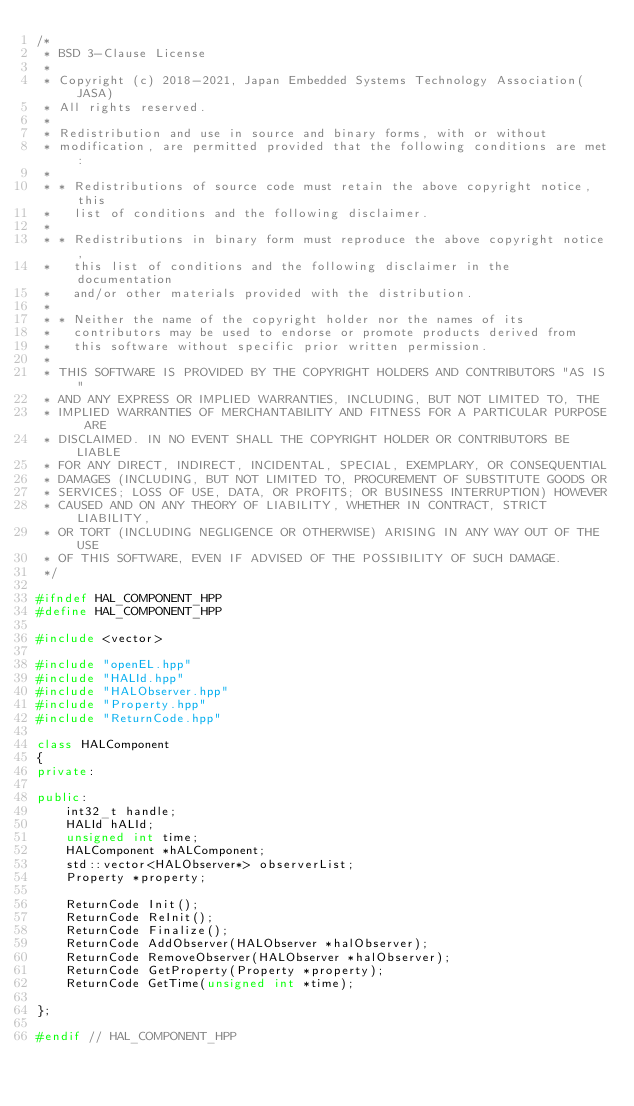Convert code to text. <code><loc_0><loc_0><loc_500><loc_500><_C++_>/*
 * BSD 3-Clause License
 *
 * Copyright (c) 2018-2021, Japan Embedded Systems Technology Association(JASA)
 * All rights reserved.
 *
 * Redistribution and use in source and binary forms, with or without
 * modification, are permitted provided that the following conditions are met:
 *
 * * Redistributions of source code must retain the above copyright notice, this
 *   list of conditions and the following disclaimer.
 *
 * * Redistributions in binary form must reproduce the above copyright notice,
 *   this list of conditions and the following disclaimer in the documentation
 *   and/or other materials provided with the distribution.
 *
 * * Neither the name of the copyright holder nor the names of its
 *   contributors may be used to endorse or promote products derived from
 *   this software without specific prior written permission.
 *
 * THIS SOFTWARE IS PROVIDED BY THE COPYRIGHT HOLDERS AND CONTRIBUTORS "AS IS"
 * AND ANY EXPRESS OR IMPLIED WARRANTIES, INCLUDING, BUT NOT LIMITED TO, THE
 * IMPLIED WARRANTIES OF MERCHANTABILITY AND FITNESS FOR A PARTICULAR PURPOSE ARE
 * DISCLAIMED. IN NO EVENT SHALL THE COPYRIGHT HOLDER OR CONTRIBUTORS BE LIABLE
 * FOR ANY DIRECT, INDIRECT, INCIDENTAL, SPECIAL, EXEMPLARY, OR CONSEQUENTIAL
 * DAMAGES (INCLUDING, BUT NOT LIMITED TO, PROCUREMENT OF SUBSTITUTE GOODS OR
 * SERVICES; LOSS OF USE, DATA, OR PROFITS; OR BUSINESS INTERRUPTION) HOWEVER
 * CAUSED AND ON ANY THEORY OF LIABILITY, WHETHER IN CONTRACT, STRICT LIABILITY,
 * OR TORT (INCLUDING NEGLIGENCE OR OTHERWISE) ARISING IN ANY WAY OUT OF THE USE
 * OF THIS SOFTWARE, EVEN IF ADVISED OF THE POSSIBILITY OF SUCH DAMAGE.
 */

#ifndef HAL_COMPONENT_HPP
#define HAL_COMPONENT_HPP

#include <vector>

#include "openEL.hpp"
#include "HALId.hpp"
#include "HALObserver.hpp"
#include "Property.hpp"
#include "ReturnCode.hpp"

class HALComponent
{
private:

public:
    int32_t handle;
    HALId hALId;
    unsigned int time;
    HALComponent *hALComponent;
    std::vector<HALObserver*> observerList;
    Property *property;

    ReturnCode Init();
    ReturnCode ReInit();
    ReturnCode Finalize();
    ReturnCode AddObserver(HALObserver *halObserver);
    ReturnCode RemoveObserver(HALObserver *halObserver);
    ReturnCode GetProperty(Property *property);
    ReturnCode GetTime(unsigned int *time);

};

#endif // HAL_COMPONENT_HPP

</code> 